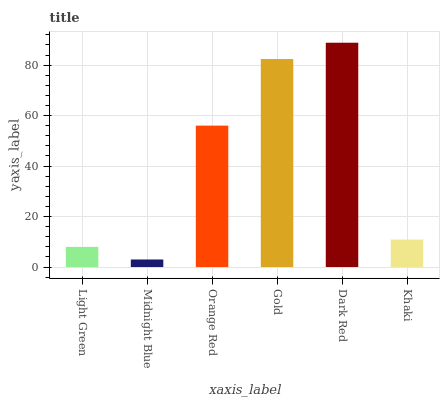Is Midnight Blue the minimum?
Answer yes or no. Yes. Is Dark Red the maximum?
Answer yes or no. Yes. Is Orange Red the minimum?
Answer yes or no. No. Is Orange Red the maximum?
Answer yes or no. No. Is Orange Red greater than Midnight Blue?
Answer yes or no. Yes. Is Midnight Blue less than Orange Red?
Answer yes or no. Yes. Is Midnight Blue greater than Orange Red?
Answer yes or no. No. Is Orange Red less than Midnight Blue?
Answer yes or no. No. Is Orange Red the high median?
Answer yes or no. Yes. Is Khaki the low median?
Answer yes or no. Yes. Is Khaki the high median?
Answer yes or no. No. Is Midnight Blue the low median?
Answer yes or no. No. 